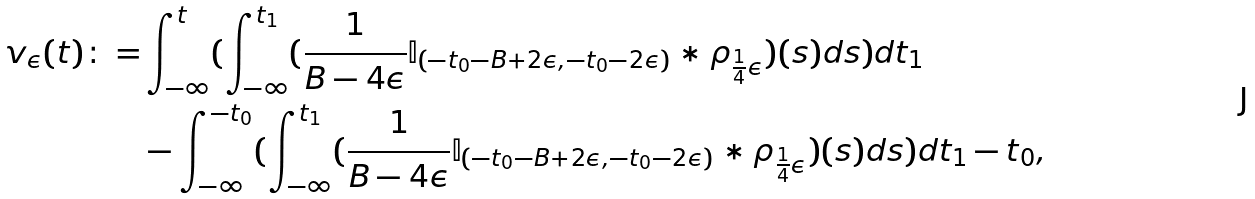Convert formula to latex. <formula><loc_0><loc_0><loc_500><loc_500>v _ { \epsilon } ( t ) \colon = & \int _ { - \infty } ^ { t } ( \int _ { - \infty } ^ { t _ { 1 } } ( \frac { 1 } { B - 4 \epsilon } \mathbb { I } _ { ( - t _ { 0 } - B + 2 \epsilon , - t _ { 0 } - 2 \epsilon ) } * \rho _ { \frac { 1 } { 4 } \epsilon } ) ( s ) d s ) d t _ { 1 } \\ & - \int _ { - \infty } ^ { - t _ { 0 } } ( \int _ { - \infty } ^ { t _ { 1 } } ( \frac { 1 } { B - 4 \epsilon } \mathbb { I } _ { ( - t _ { 0 } - B + 2 \epsilon , - t _ { 0 } - 2 \epsilon ) } * \rho _ { \frac { 1 } { 4 } \epsilon } ) ( s ) d s ) d t _ { 1 } - t _ { 0 } ,</formula> 